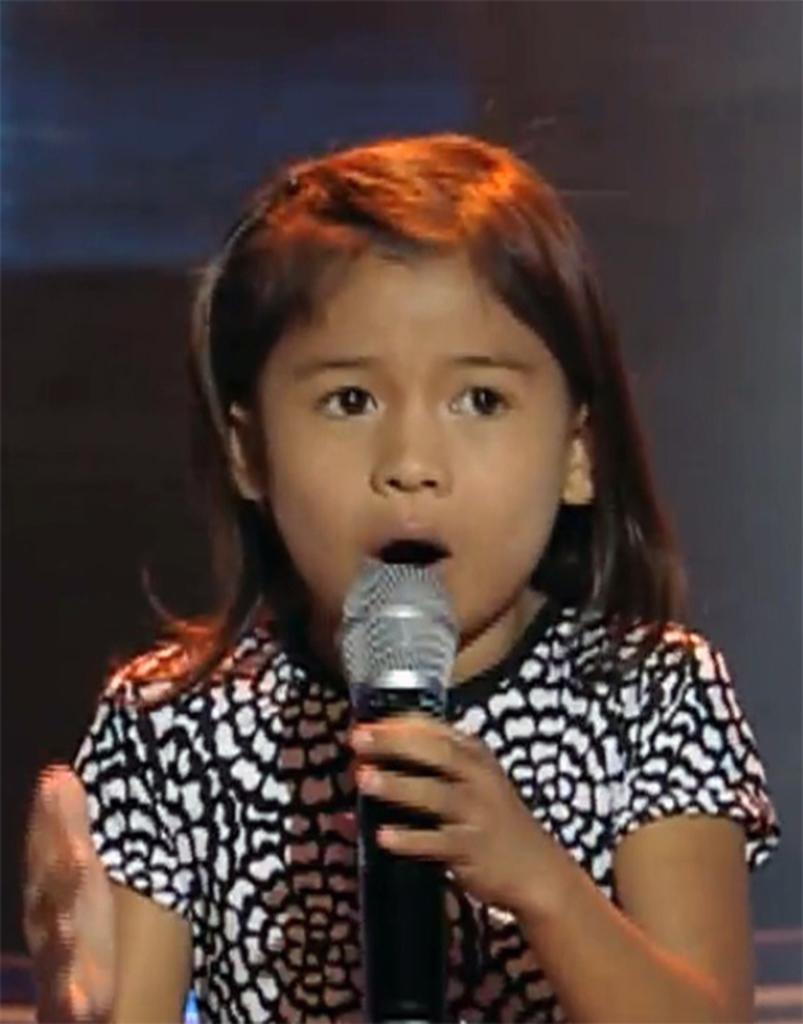Who is the main subject in the image? There is a girl in the image. What is the girl doing in the image? The girl is talking in the image. What object is the girl using while talking? The girl is using a microphone in the image. What type of mint is growing on the girl's head in the image? There is no mint or any plant growing on the girl's head in the image. 